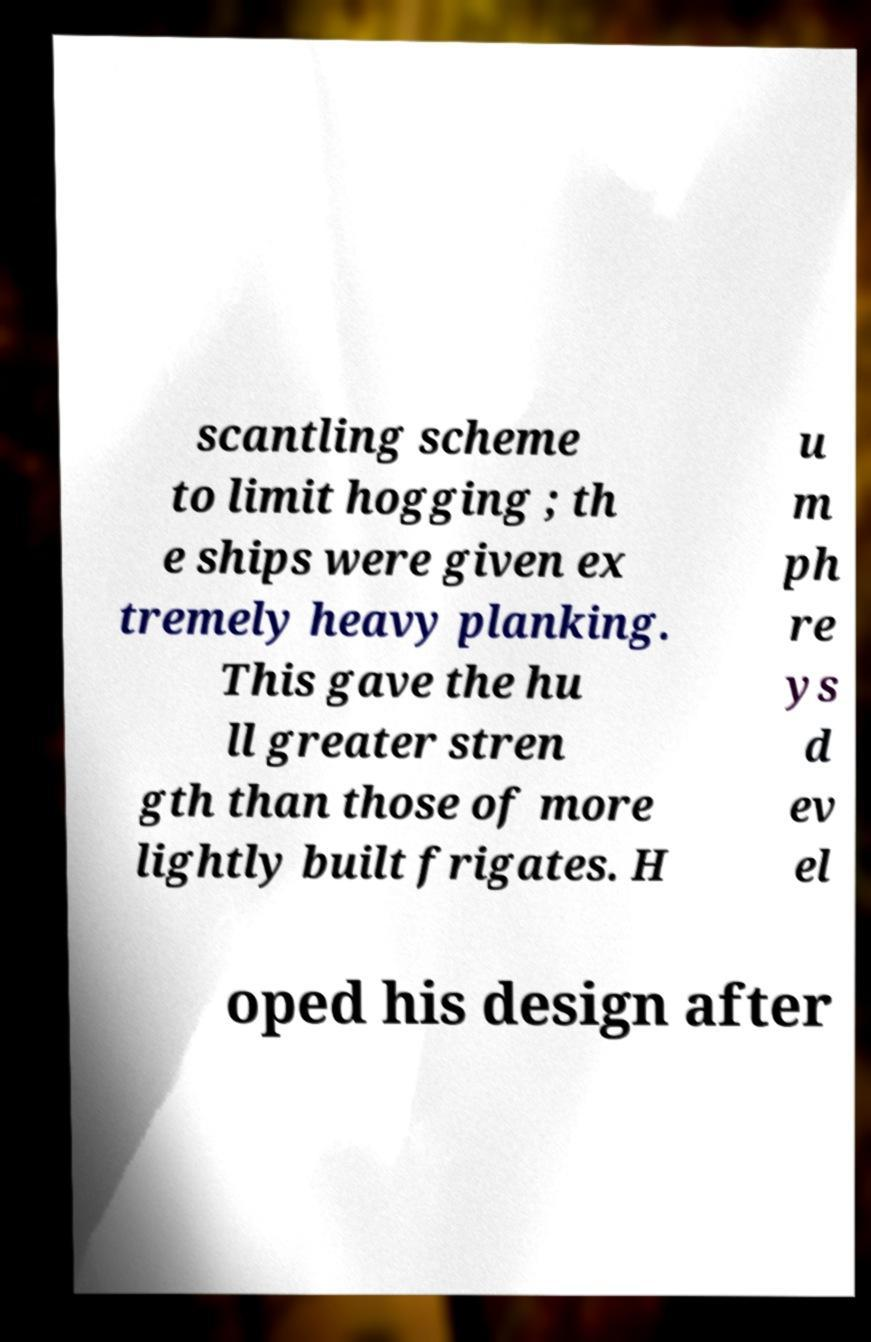Could you extract and type out the text from this image? scantling scheme to limit hogging ; th e ships were given ex tremely heavy planking. This gave the hu ll greater stren gth than those of more lightly built frigates. H u m ph re ys d ev el oped his design after 